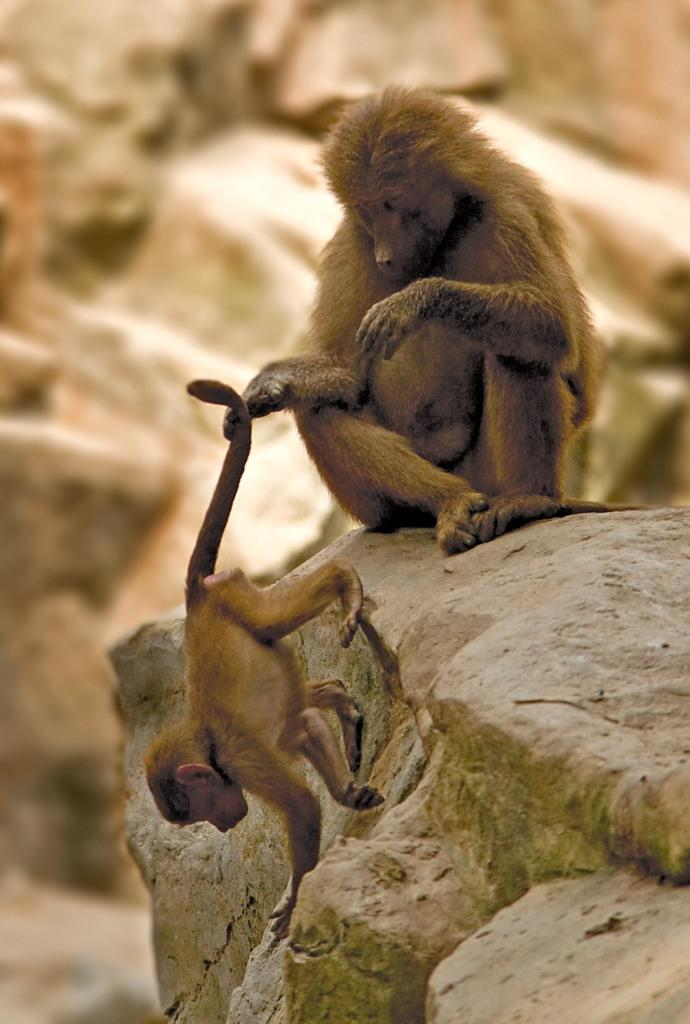How many monkeys are in the image? There are two monkeys in the image. What color are the monkeys? The monkeys are brown in color. Where are the monkeys sitting in the image? The monkeys are sitting on a rock. What type of blade is the monkey holding in the image? There is no blade present in the image; the monkeys are simply sitting on a rock. 